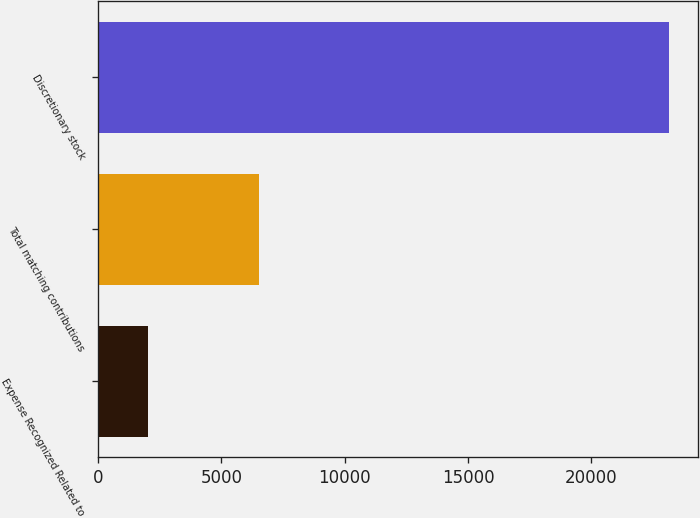<chart> <loc_0><loc_0><loc_500><loc_500><bar_chart><fcel>Expense Recognized Related to<fcel>Total matching contributions<fcel>Discretionary stock<nl><fcel>2016<fcel>6546<fcel>23158<nl></chart> 